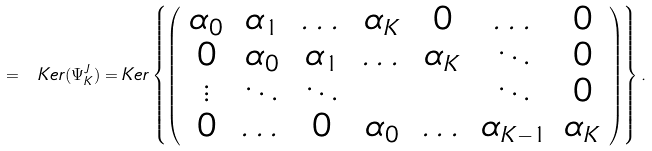<formula> <loc_0><loc_0><loc_500><loc_500>= \ K e r ( \Psi _ { K } ^ { J } ) = K e r \left \{ \left ( \begin{array} { c c c c c c c c } \alpha _ { 0 } & \alpha _ { 1 } & \dots & \alpha _ { K } & 0 & \dots & 0 \\ 0 & \alpha _ { 0 } & \alpha _ { 1 } & \dots & \alpha _ { K } & \ddots & 0 \\ \vdots & \ddots & \ddots & & & \ddots & 0 \\ 0 & \dots & 0 & \alpha _ { 0 } & \dots & \alpha _ { K - 1 } & \alpha _ { K } \\ \end{array} \right ) \right \} .</formula> 